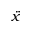Convert formula to latex. <formula><loc_0><loc_0><loc_500><loc_500>\ddot { x }</formula> 